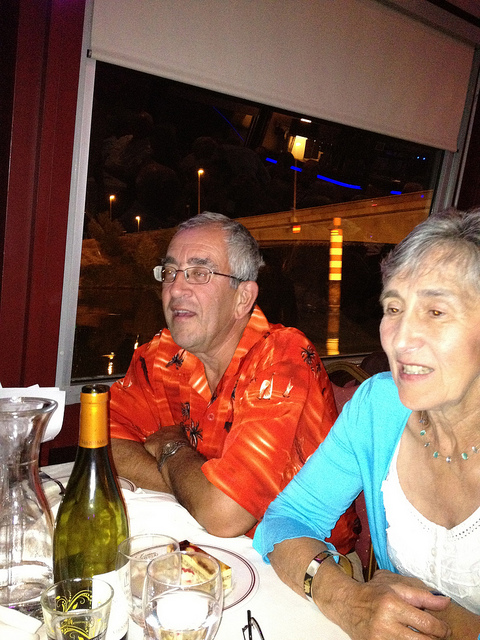Please provide a short description for this region: [0.51, 0.32, 0.87, 0.99]. A woman with short gray hair, wearing a light blue cardigan. 